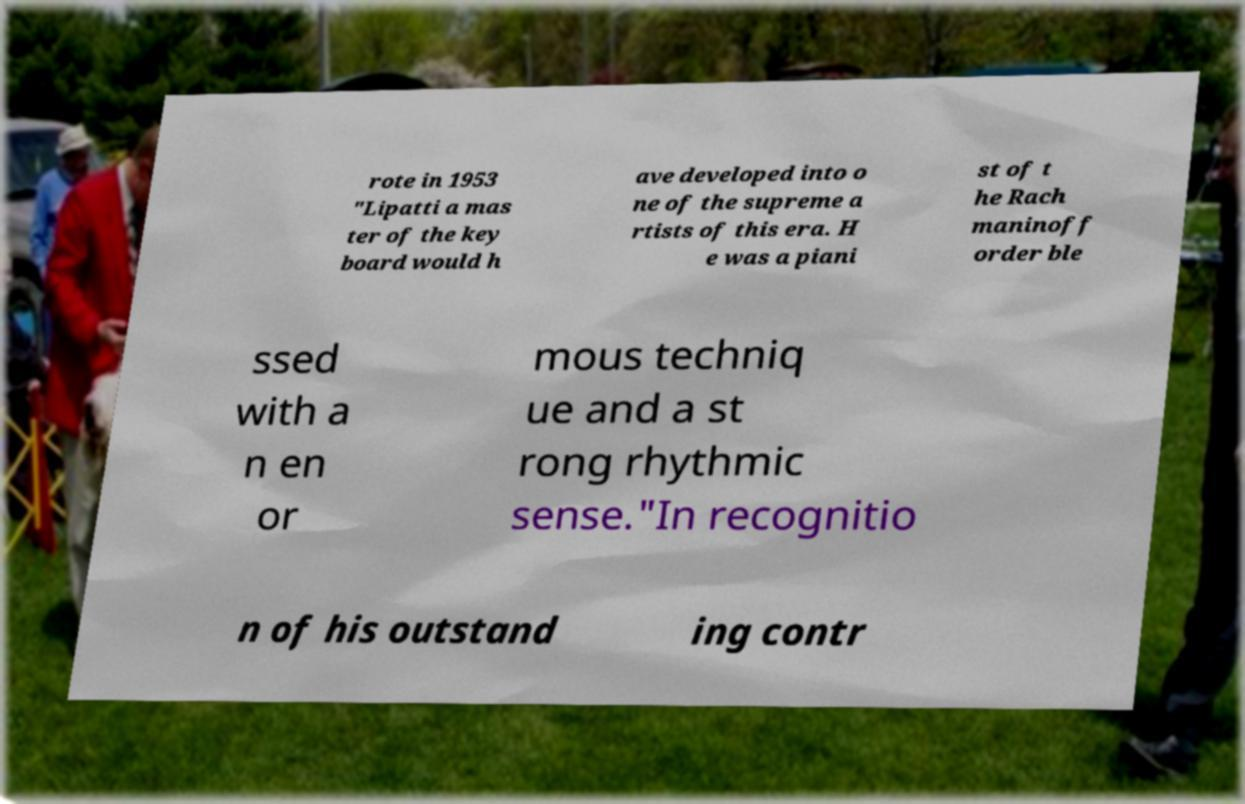Can you accurately transcribe the text from the provided image for me? rote in 1953 "Lipatti a mas ter of the key board would h ave developed into o ne of the supreme a rtists of this era. H e was a piani st of t he Rach maninoff order ble ssed with a n en or mous techniq ue and a st rong rhythmic sense."In recognitio n of his outstand ing contr 